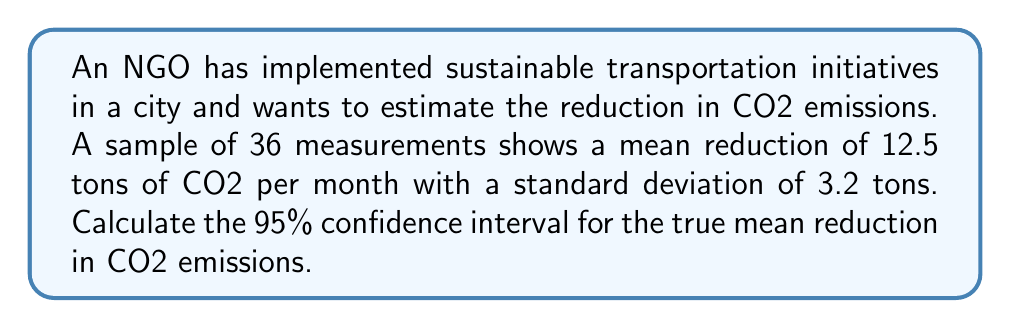Show me your answer to this math problem. To calculate the confidence interval, we'll follow these steps:

1) The formula for the confidence interval is:

   $$\bar{x} \pm t_{\alpha/2} \cdot \frac{s}{\sqrt{n}}$$

   Where:
   $\bar{x}$ is the sample mean
   $t_{\alpha/2}$ is the t-value for the desired confidence level
   $s$ is the sample standard deviation
   $n$ is the sample size

2) We have:
   $\bar{x} = 12.5$ tons
   $s = 3.2$ tons
   $n = 36$
   Confidence level = 95%, so $\alpha = 0.05$

3) For a 95% confidence interval with 35 degrees of freedom (n-1), the t-value is approximately 2.030 (from t-distribution table).

4) Plugging into the formula:

   $$12.5 \pm 2.030 \cdot \frac{3.2}{\sqrt{36}}$$

5) Simplify:
   $$12.5 \pm 2.030 \cdot \frac{3.2}{6} = 12.5 \pm 2.030 \cdot 0.533 = 12.5 \pm 1.082$$

6) Therefore, the confidence interval is:
   $$(12.5 - 1.082, 12.5 + 1.082) = (11.418, 13.582)$$
Answer: (11.418, 13.582) tons of CO2 per month 